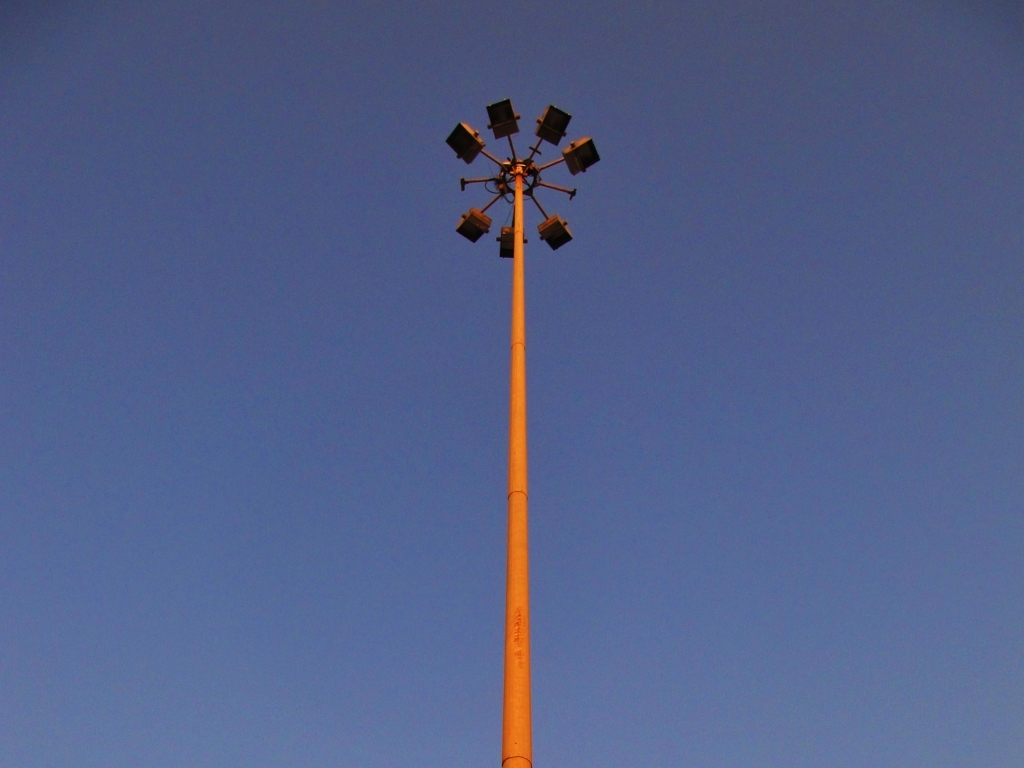Is there any distortion in the image? The image appears to have no noticeable distortion. It captures a cluster of floodlights mounted high on a pole against a clear evening sky, with consistent lighting and colors across the composition. 